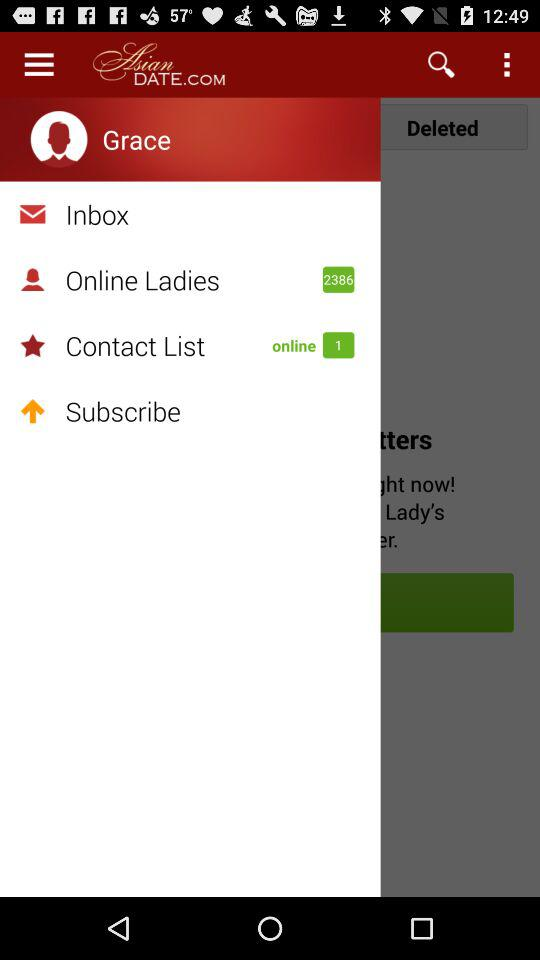How many of them are online from my contact list? From my contact list, there is 1 online person. 